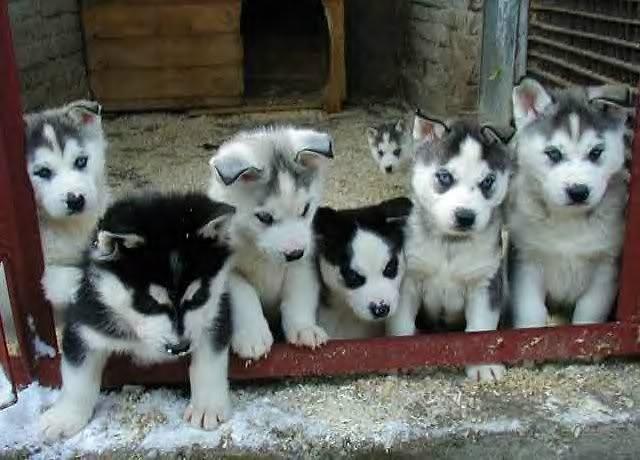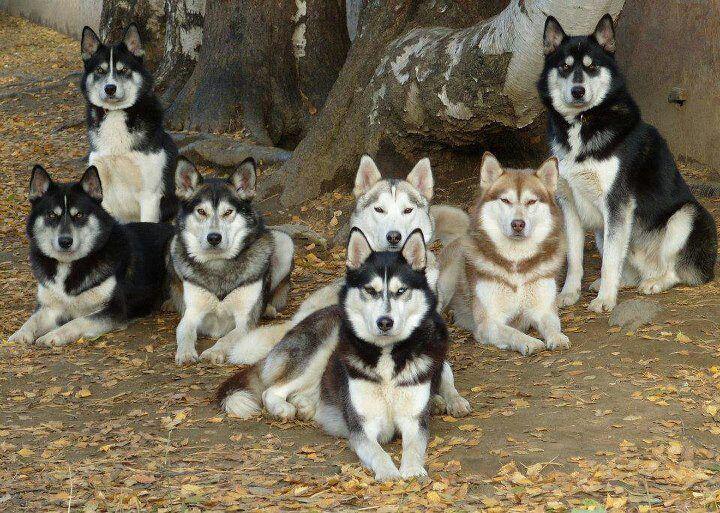The first image is the image on the left, the second image is the image on the right. Considering the images on both sides, is "One image shows four husky dogs wearing different colored collars with dangling charms, and at least three of the dogs sit upright and face forward." valid? Answer yes or no. No. The first image is the image on the left, the second image is the image on the right. Examine the images to the left and right. Is the description "There are exactly eight dogs." accurate? Answer yes or no. No. 